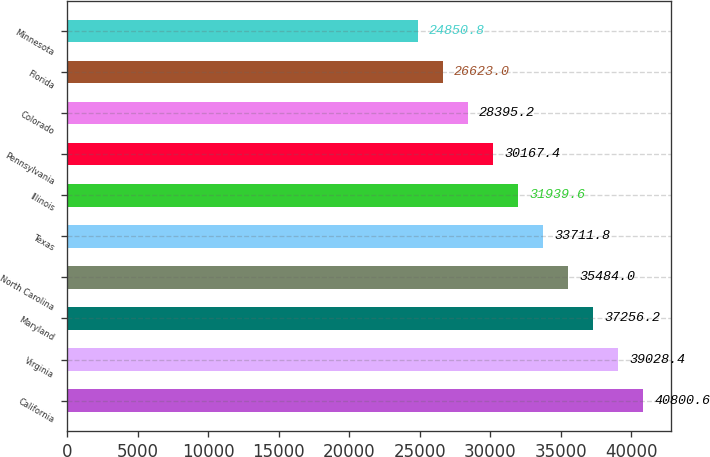<chart> <loc_0><loc_0><loc_500><loc_500><bar_chart><fcel>California<fcel>Virginia<fcel>Maryland<fcel>North Carolina<fcel>Texas<fcel>Illinois<fcel>Pennsylvania<fcel>Colorado<fcel>Florida<fcel>Minnesota<nl><fcel>40800.6<fcel>39028.4<fcel>37256.2<fcel>35484<fcel>33711.8<fcel>31939.6<fcel>30167.4<fcel>28395.2<fcel>26623<fcel>24850.8<nl></chart> 